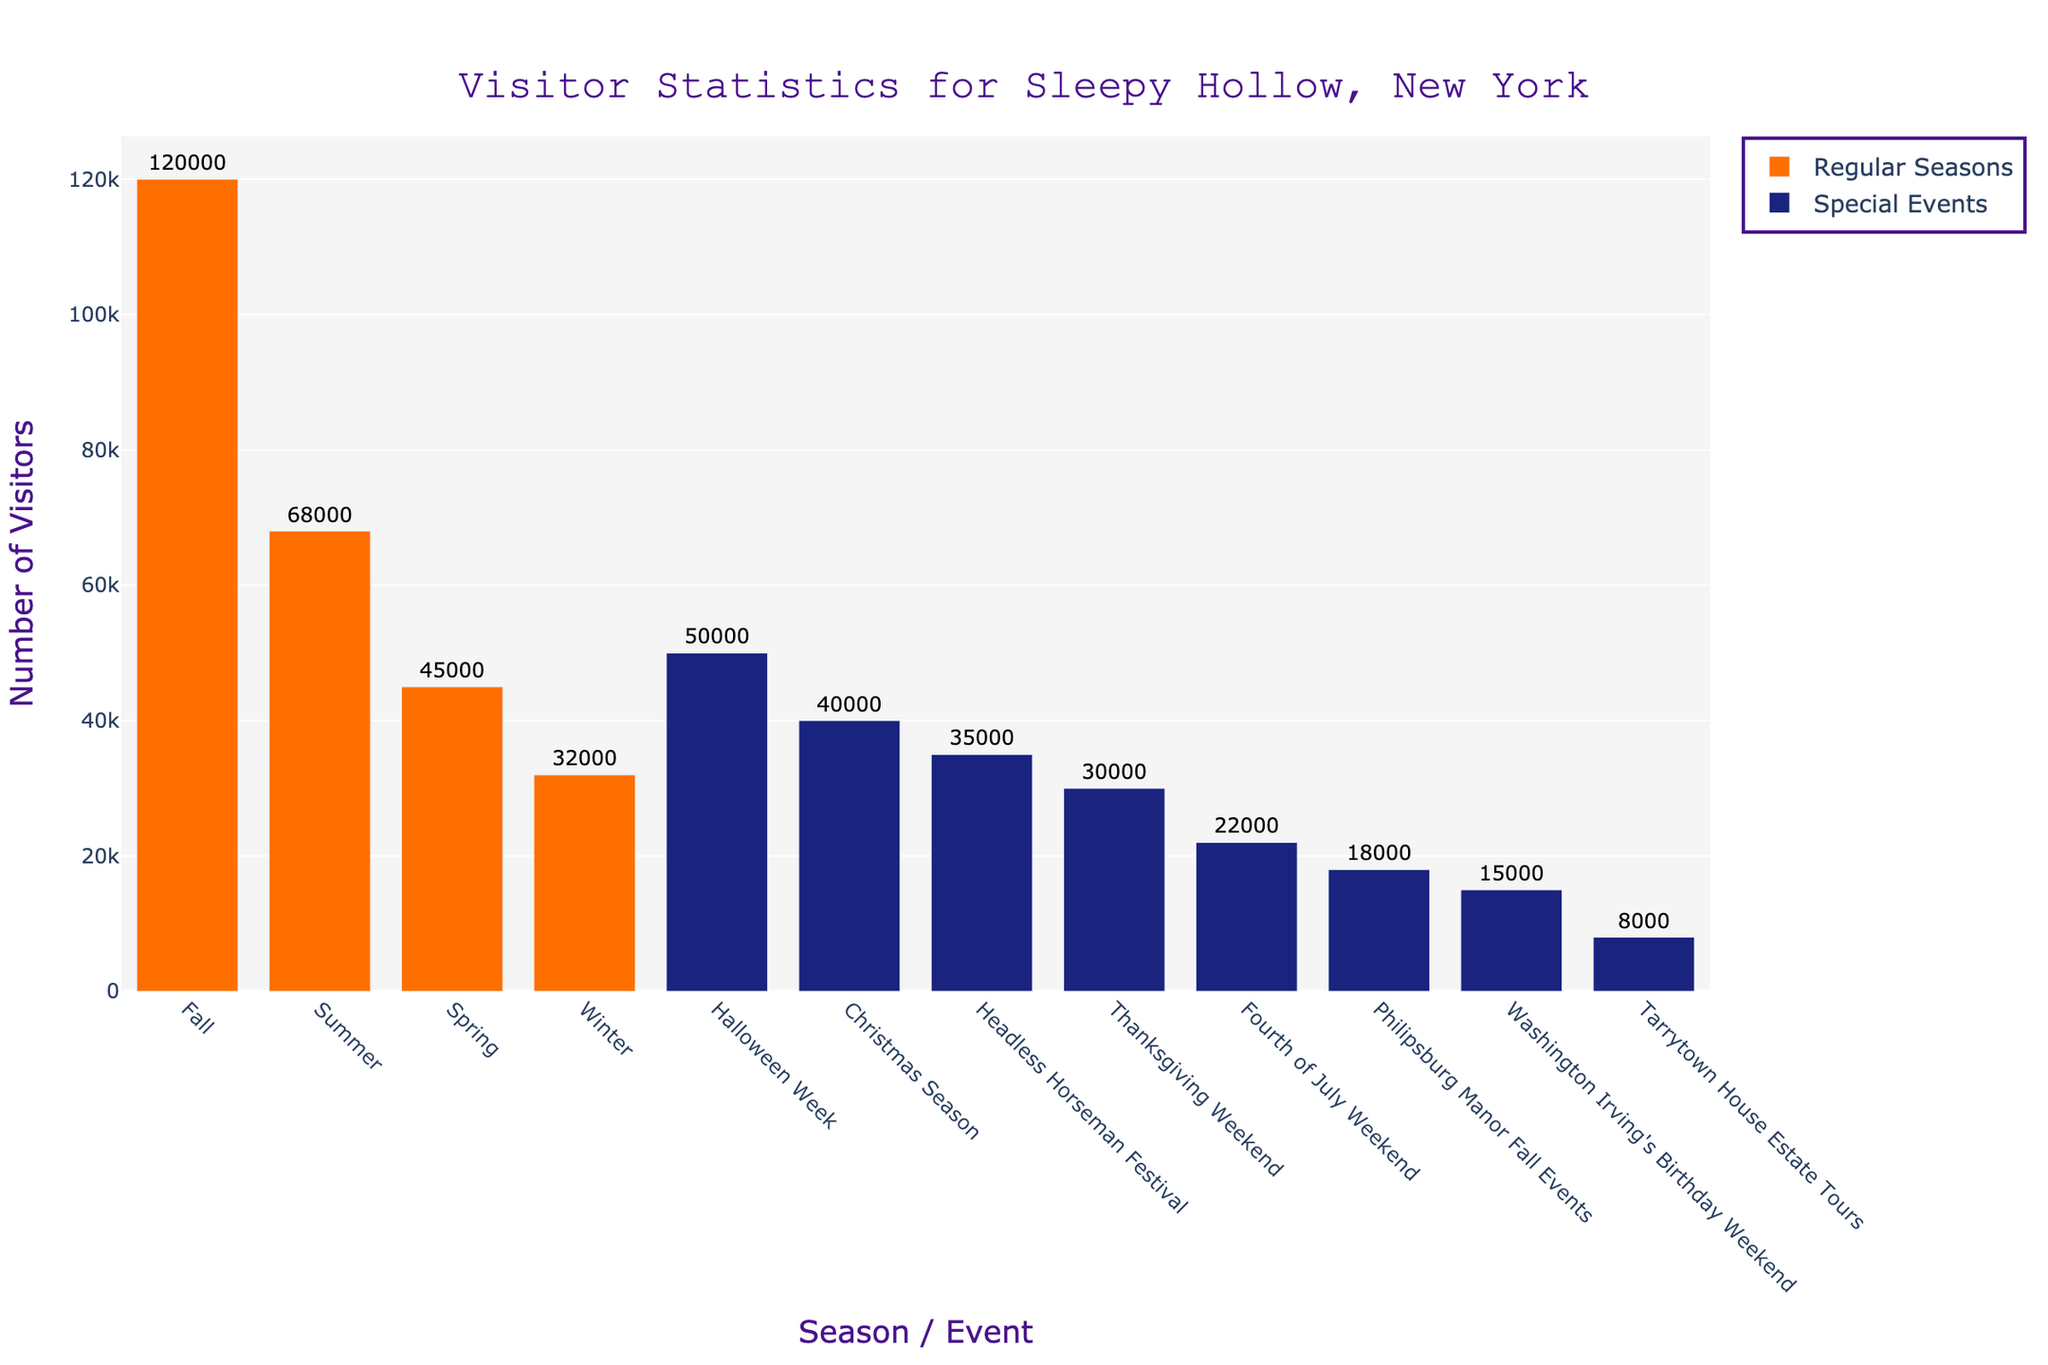Which season or event had the highest number of visitors? The Fall season had the highest bar, indicating the largest number of visitors.
Answer: Fall How many more visitors did Summer have compared to Winter? Subtract the number of visitors in Winter (32,000) from the number of visitors in Summer (68,000). The difference is 36,000.
Answer: 36,000 Which special event had the least number of visitors? Tarrytown House Estate Tours has the smallest bar among special events, indicating the fewest number of visitors.
Answer: Tarrytown House Estate Tours How many visitors did Sleepy Hollow attract in total during the regular seasons? Sum the number of visitors in Spring (45,000), Summer (68,000), Fall (120,000), and Winter (32,000). The total is 265,000.
Answer: 265,000 What is the average number of visitors for the special events? Add the number of visitors for each special event (50,000 + 40,000 + 15,000 + 22,000 + 30,000 + 35,000 + 8,000 + 18,000) and divide by the number of special events (8). The average is 218,000 / 8 = 27,250.
Answer: 27,250 Which season attracts fewer visitors: Spring or Christmas Season? Compare the heights of the bars for Spring (45,000) and Christmas Season (40,000). The bar for Christmas Season is shorter.
Answer: Christmas Season What is the combined total number of visitors for Fall and Halloween Week? Add the number of visitors in Fall (120,000) and Halloween Week (50,000). The combined total is 170,000.
Answer: 170,000 How does the number of visitors during Thanksgiving Weekend compare to Washington Irving's Birthday Weekend? Compare the heights of the bars for Thanksgiving Weekend (30,000) and Washington Irving's Birthday Weekend (15,000). The bar for Thanksgiving Weekend is taller.
Answer: Thanksgiving Weekend What's the median number of visitors for the events: Halloween Week, Christmas Season, Fourth of July Weekend, Thanksgiving Weekend, and Headless Horseman Festival? Sort the visitor numbers for the events (50,000, 40,000, 22,000, 30,000, 35,000) and find the middle value. The sorted list is (22,000, 30,000, 35,000, 40,000, 50,000) with 35,000 as the median.
Answer: 35,000 Which season or event had approximately twice the visitors compared to Thanksgiving Weekend? Thanksgiving Weekend had 30,000 visitors. The event with approximately twice the visitors is Halloween Week with 50,000 visitors.
Answer: Halloween Week 